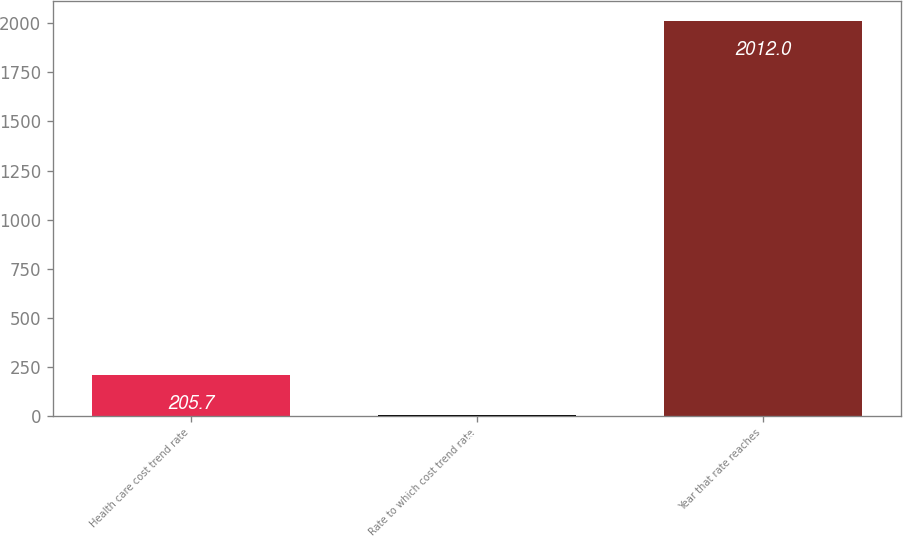Convert chart. <chart><loc_0><loc_0><loc_500><loc_500><bar_chart><fcel>Health care cost trend rate<fcel>Rate to which cost trend rate<fcel>Year that rate reaches<nl><fcel>205.7<fcel>5<fcel>2012<nl></chart> 